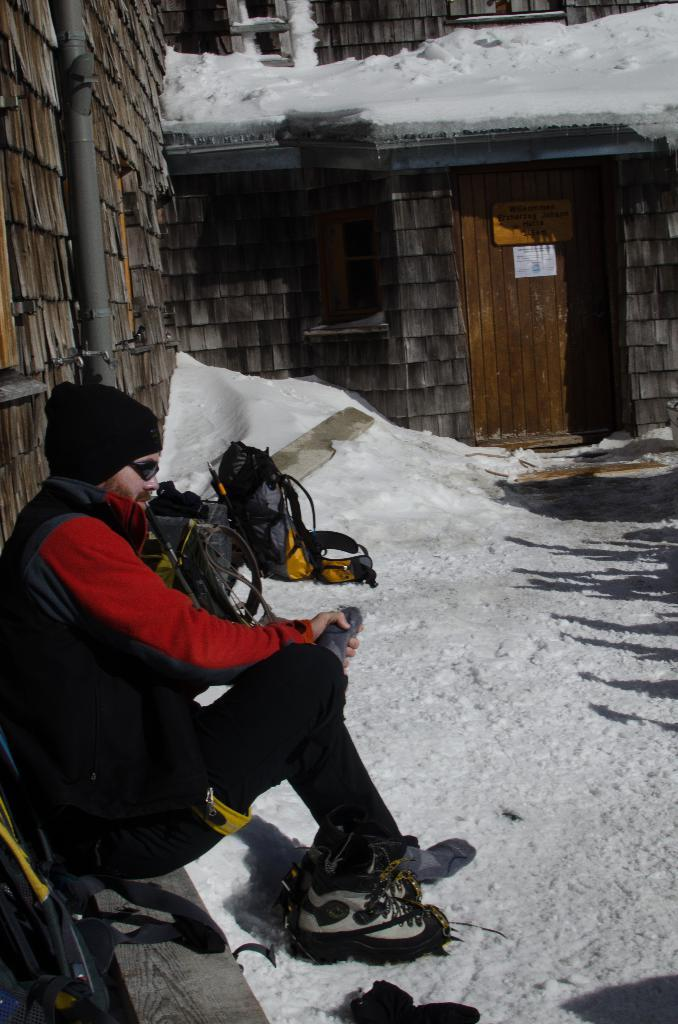What is the man in the image doing? The man is sitting in the image. What accessories is the man wearing? The man is wearing a cap and shades. What type of footwear is the man wearing? The man is wearing shoes. What type of clothing is the man wearing? The man is wearing clothes. What can be seen in the background of the image? There is a house, snow, a bag, and other objects on the ground in the background of the image. What type of jeans is the man wearing in the image? There is no mention of jeans in the provided facts, so we cannot determine the type of jeans the man is wearing. What type of corn can be seen growing in the background of the image? There is no corn present in the image; the background features a house, snow, a bag, and other objects on the ground. 